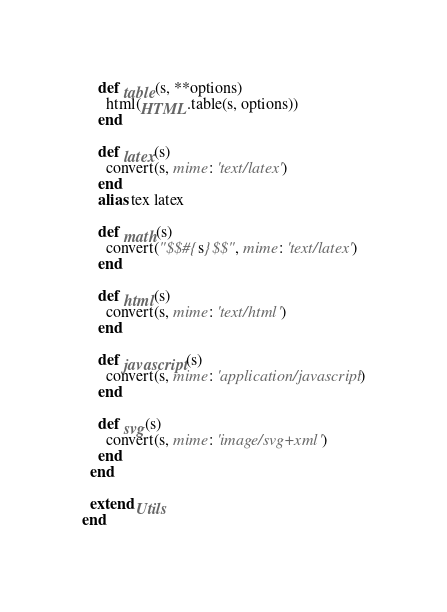<code> <loc_0><loc_0><loc_500><loc_500><_Ruby_>    def table(s, **options)
      html(HTML.table(s, options))
    end

    def latex(s)
      convert(s, mime: 'text/latex')
    end
    alias tex latex

    def math(s)
      convert("$$#{s}$$", mime: 'text/latex')
    end

    def html(s)
      convert(s, mime: 'text/html')
    end

    def javascript(s)
      convert(s, mime: 'application/javascript')
    end

    def svg(s)
      convert(s, mime: 'image/svg+xml')
    end
  end

  extend Utils
end
</code> 